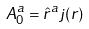Convert formula to latex. <formula><loc_0><loc_0><loc_500><loc_500>A _ { 0 } ^ { a } = \hat { r } ^ { a } j ( r )</formula> 